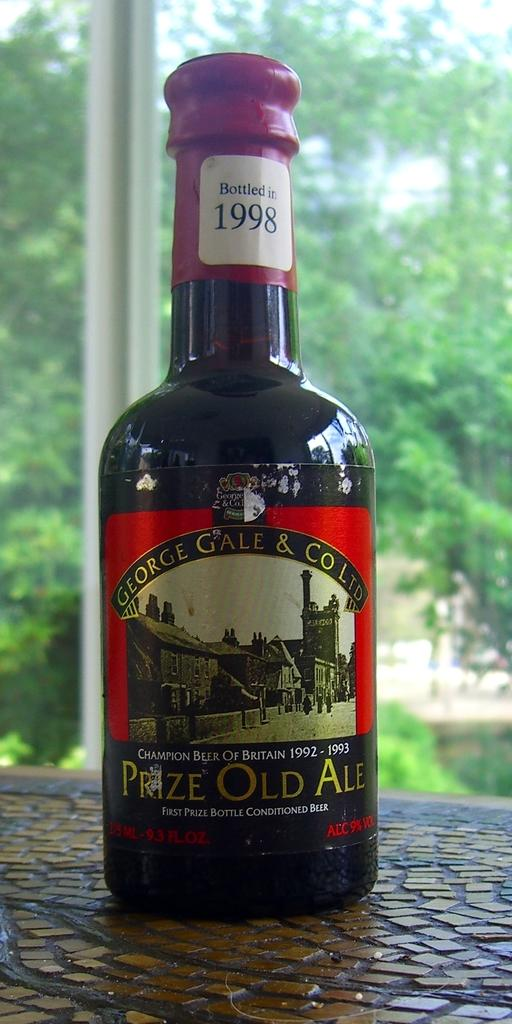<image>
Create a compact narrative representing the image presented. A bottle of Prize Old Ale Beer a champion beer from Britain sits on a table outside. 